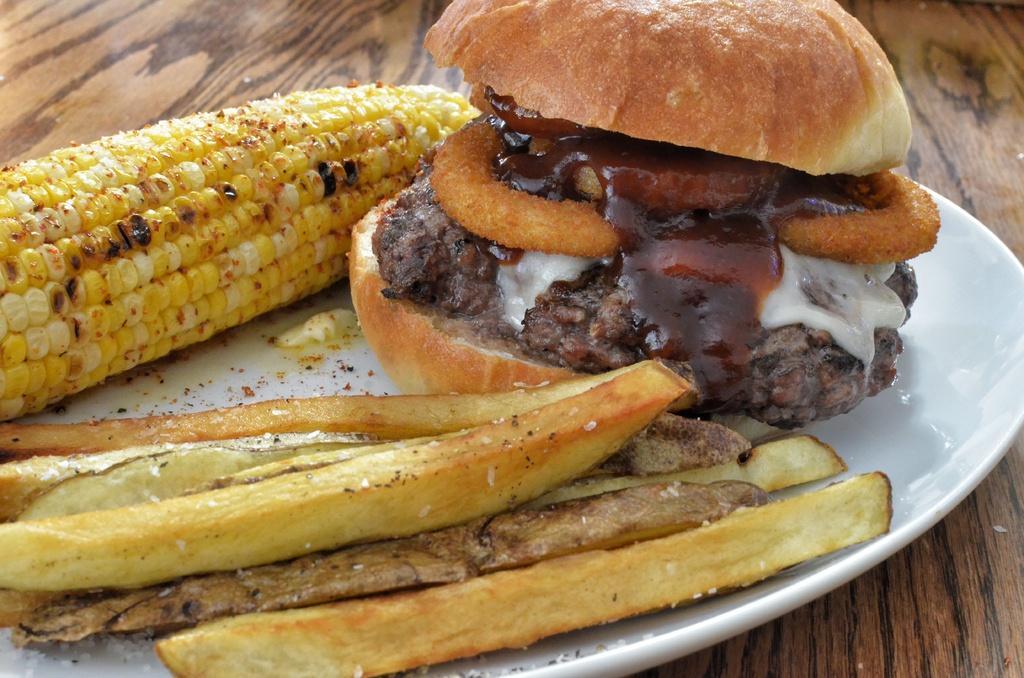Describe this image in one or two sentences. In this picture we can see some food items on a plate. This plate is on a wooden surface. 